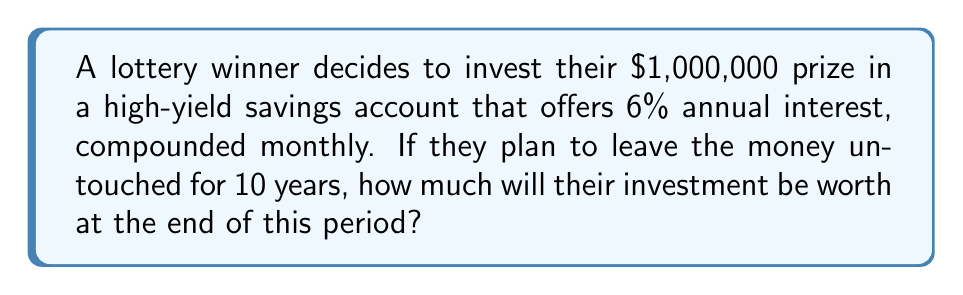Teach me how to tackle this problem. To solve this problem, we'll use the compound interest formula:

$$A = P(1 + \frac{r}{n})^{nt}$$

Where:
$A$ = final amount
$P$ = principal (initial investment)
$r$ = annual interest rate (as a decimal)
$n$ = number of times interest is compounded per year
$t$ = number of years

Given:
$P = \$1,000,000$
$r = 0.06$ (6% expressed as a decimal)
$n = 12$ (compounded monthly)
$t = 10$ years

Let's substitute these values into the formula:

$$A = 1,000,000(1 + \frac{0.06}{12})^{12 \cdot 10}$$

$$A = 1,000,000(1 + 0.005)^{120}$$

$$A = 1,000,000(1.005)^{120}$$

Using a calculator:

$$A = 1,000,000 \cdot 1.8194097$$

$$A = 1,819,409.70$$

Therefore, after 10 years, the investment will be worth $1,819,409.70.
Answer: $1,819,409.70 